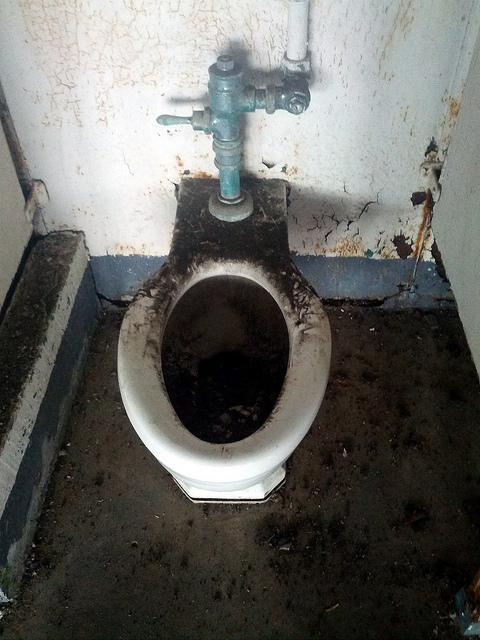Is the toilet clean?
Concise answer only. No. What room is this?
Give a very brief answer. Bathroom. Is there a sink in the room?
Answer briefly. No. 